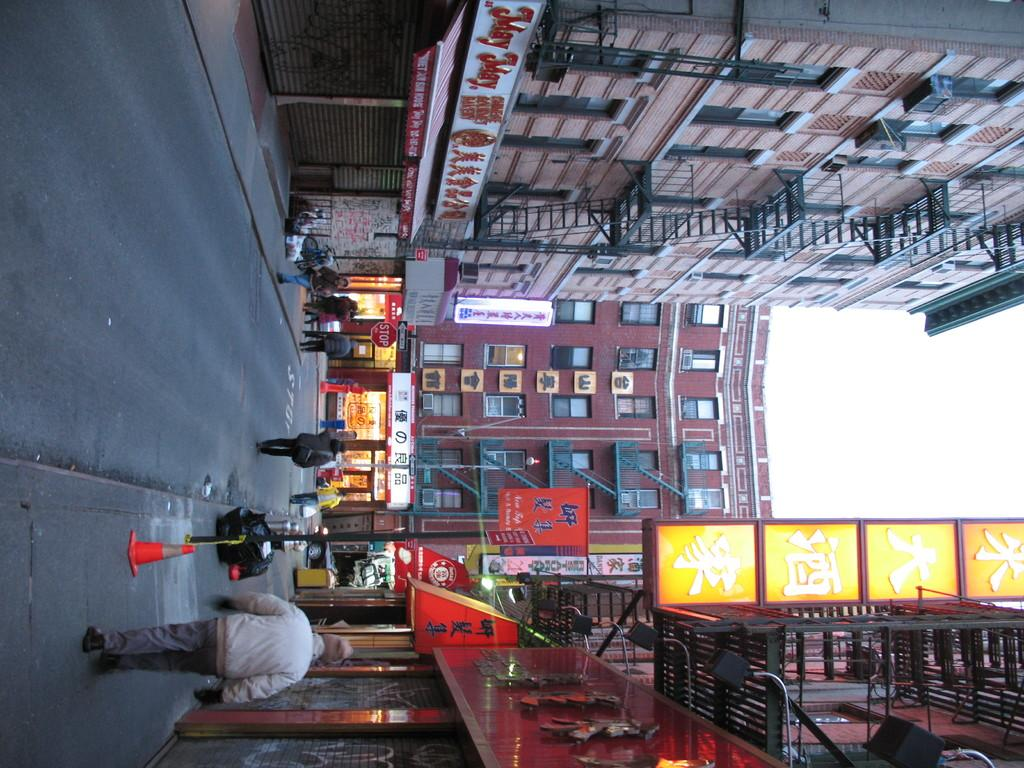What are the people in the image doing? The people in the image are walking on the streets. What can be seen in front of the street? There is a building with shops in front of the street. What is the surrounding environment of the shops? There are buildings on either side of the shops. What type of sticks can be seen being used for digestion in the image? There are no sticks or any reference to digestion present in the image. 